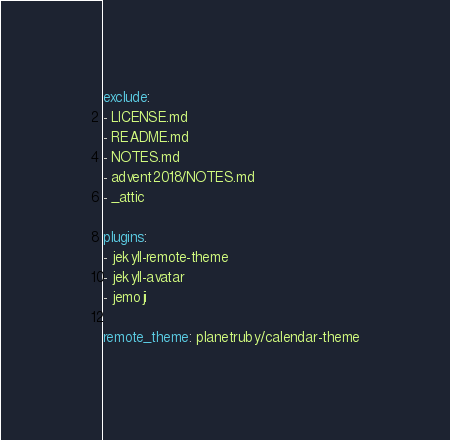Convert code to text. <code><loc_0><loc_0><loc_500><loc_500><_YAML_>
exclude:
- LICENSE.md
- README.md
- NOTES.md
- advent2018/NOTES.md
- _attic

plugins:
- jekyll-remote-theme
- jekyll-avatar
- jemoji

remote_theme: planetruby/calendar-theme
</code> 